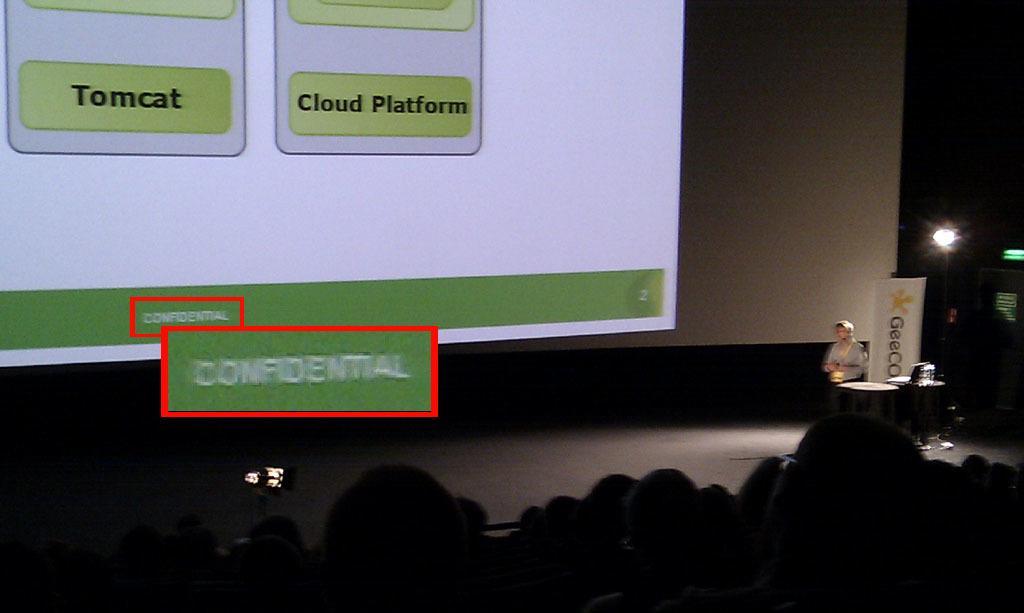Can you describe this image briefly? On the right side of the image we can see a person standing. There is a podium. At the bottom there is crowd. In the background we can see a screen. There is a light. 